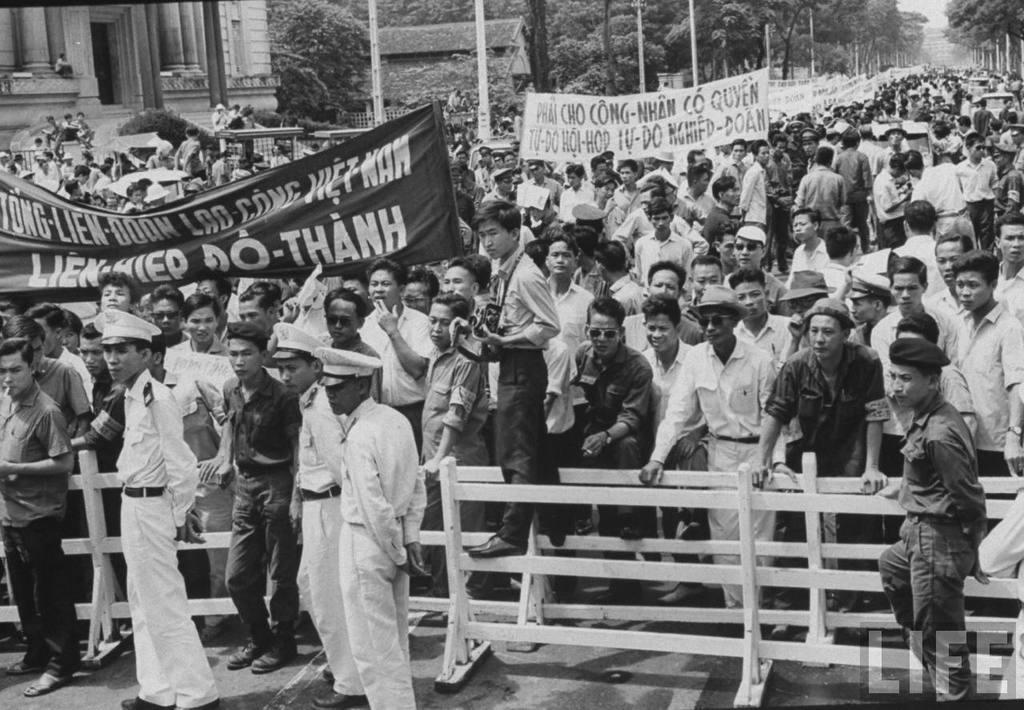In one or two sentences, can you explain what this image depicts? This is a black and white picture. In this picture, we see many people are standing. The man in the middle of the picture is holding a camera in his hand. In front of the picture, we see a railing and beside that, we see three men in the uniform are standing. Here, we see people are holding white and black banners with some text written on it. There are trees, poles and buildings in the background. I think they are protesting against something. 